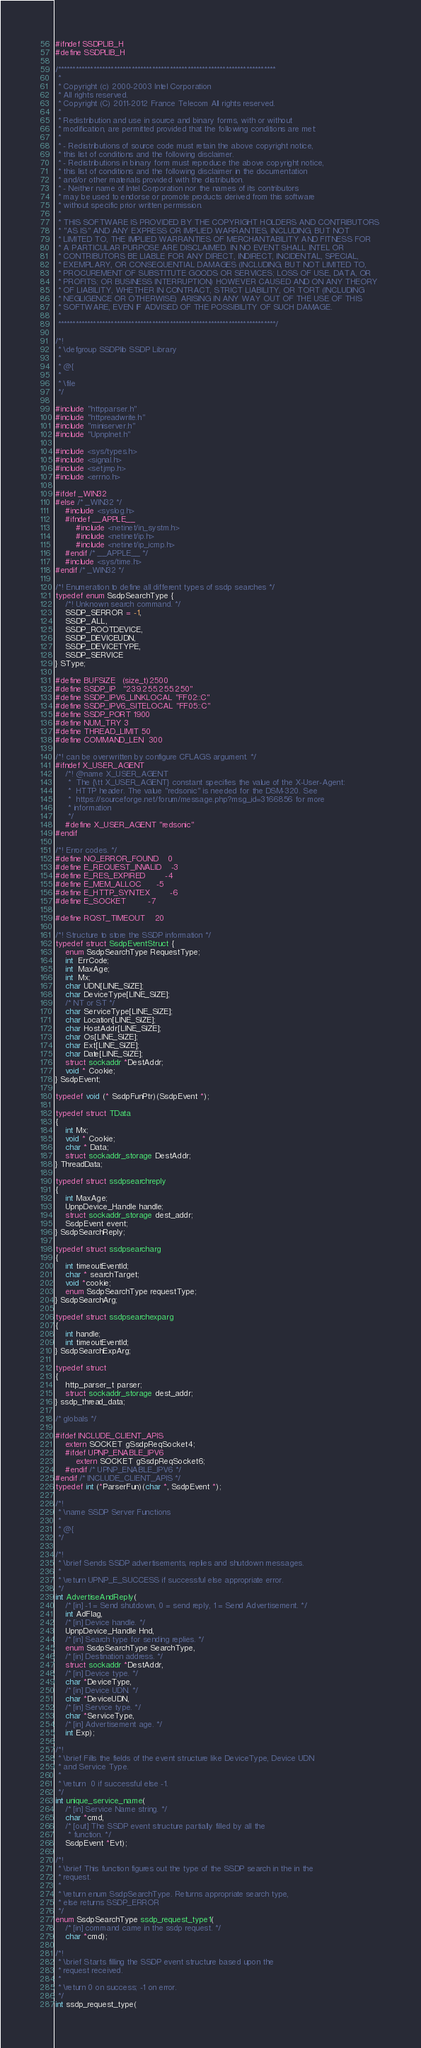<code> <loc_0><loc_0><loc_500><loc_500><_C_>#ifndef SSDPLIB_H
#define SSDPLIB_H 

/**************************************************************************
 *
 * Copyright (c) 2000-2003 Intel Corporation 
 * All rights reserved. 
 * Copyright (C) 2011-2012 France Telecom All rights reserved. 
 *
 * Redistribution and use in source and binary forms, with or without 
 * modification, are permitted provided that the following conditions are met: 
 *
 * - Redistributions of source code must retain the above copyright notice, 
 * this list of conditions and the following disclaimer. 
 * - Redistributions in binary form must reproduce the above copyright notice, 
 * this list of conditions and the following disclaimer in the documentation 
 * and/or other materials provided with the distribution. 
 * - Neither name of Intel Corporation nor the names of its contributors 
 * may be used to endorse or promote products derived from this software 
 * without specific prior written permission.
 * 
 * THIS SOFTWARE IS PROVIDED BY THE COPYRIGHT HOLDERS AND CONTRIBUTORS 
 * "AS IS" AND ANY EXPRESS OR IMPLIED WARRANTIES, INCLUDING, BUT NOT 
 * LIMITED TO, THE IMPLIED WARRANTIES OF MERCHANTABILITY AND FITNESS FOR 
 * A PARTICULAR PURPOSE ARE DISCLAIMED. IN NO EVENT SHALL INTEL OR 
 * CONTRIBUTORS BE LIABLE FOR ANY DIRECT, INDIRECT, INCIDENTAL, SPECIAL, 
 * EXEMPLARY, OR CONSEQUENTIAL DAMAGES (INCLUDING, BUT NOT LIMITED TO, 
 * PROCUREMENT OF SUBSTITUTE GOODS OR SERVICES; LOSS OF USE, DATA, OR 
 * PROFITS; OR BUSINESS INTERRUPTION) HOWEVER CAUSED AND ON ANY THEORY 
 * OF LIABILITY, WHETHER IN CONTRACT, STRICT LIABILITY, OR TORT (INCLUDING
 * NEGLIGENCE OR OTHERWISE) ARISING IN ANY WAY OUT OF THE USE OF THIS 
 * SOFTWARE, EVEN IF ADVISED OF THE POSSIBILITY OF SUCH DAMAGE.
 *
 **************************************************************************/

/*!
 * \defgroup SSDPlib SSDP Library
 *
 * @{
 *
 * \file
 */

#include "httpparser.h"
#include "httpreadwrite.h"
#include "miniserver.h"
#include "UpnpInet.h"

#include <sys/types.h>
#include <signal.h>
#include <setjmp.h>
#include <errno.h>

#ifdef _WIN32
#else /* _WIN32 */
	#include <syslog.h>
	#ifndef __APPLE__
		#include <netinet/in_systm.h>
		#include <netinet/ip.h>
		#include <netinet/ip_icmp.h>
	#endif /* __APPLE__ */
	#include <sys/time.h>
#endif /* _WIN32 */

/*! Enumeration to define all different types of ssdp searches */
typedef enum SsdpSearchType {
	/*! Unknown search command. */
	SSDP_SERROR = -1,
	SSDP_ALL,
	SSDP_ROOTDEVICE,
	SSDP_DEVICEUDN,
	SSDP_DEVICETYPE,
	SSDP_SERVICE
} SType;

#define BUFSIZE   (size_t)2500
#define SSDP_IP   "239.255.255.250"
#define SSDP_IPV6_LINKLOCAL "FF02::C"
#define SSDP_IPV6_SITELOCAL "FF05::C"
#define SSDP_PORT 1900
#define NUM_TRY 3
#define THREAD_LIMIT 50
#define COMMAND_LEN  300

/*! can be overwritten by configure CFLAGS argument. */
#ifndef X_USER_AGENT
	/*! @name X_USER_AGENT
	 *  The {\tt X_USER_AGENT} constant specifies the value of the X-User-Agent:
	 *  HTTP header. The value "redsonic" is needed for the DSM-320. See
	 *  https://sourceforge.net/forum/message.php?msg_id=3166856 for more
	 * information
	 */
	#define X_USER_AGENT "redsonic"
#endif

/*! Error codes. */
#define NO_ERROR_FOUND    0
#define E_REQUEST_INVALID  	-3
#define E_RES_EXPIRED		-4
#define E_MEM_ALLOC		-5
#define E_HTTP_SYNTEX		-6
#define E_SOCKET 		-7

#define RQST_TIMEOUT    20

/*! Structure to store the SSDP information */
typedef struct SsdpEventStruct {
	enum SsdpSearchType RequestType;
	int  ErrCode;
	int  MaxAge;
	int  Mx;
	char UDN[LINE_SIZE];
	char DeviceType[LINE_SIZE];
	/* NT or ST */
	char ServiceType[LINE_SIZE];
	char Location[LINE_SIZE];
	char HostAddr[LINE_SIZE];
	char Os[LINE_SIZE];
	char Ext[LINE_SIZE];
	char Date[LINE_SIZE];
	struct sockaddr *DestAddr;
	void * Cookie;
} SsdpEvent;

typedef void (* SsdpFunPtr)(SsdpEvent *);

typedef struct TData
{
	int Mx;
	void * Cookie;
	char * Data;
	struct sockaddr_storage DestAddr;
} ThreadData;

typedef struct ssdpsearchreply
{
	int MaxAge;
	UpnpDevice_Handle handle;
	struct sockaddr_storage dest_addr;
	SsdpEvent event;
} SsdpSearchReply;

typedef struct ssdpsearcharg
{
	int timeoutEventId;
	char * searchTarget;
	void *cookie;
	enum SsdpSearchType requestType;
} SsdpSearchArg;

typedef struct ssdpsearchexparg
{
	int handle;
	int timeoutEventId;
} SsdpSearchExpArg;

typedef struct
{
	http_parser_t parser;
	struct sockaddr_storage dest_addr;
} ssdp_thread_data;

/* globals */

#ifdef INCLUDE_CLIENT_APIS
	extern SOCKET gSsdpReqSocket4;
	#ifdef UPNP_ENABLE_IPV6
		extern SOCKET gSsdpReqSocket6;
	#endif /* UPNP_ENABLE_IPV6 */
#endif /* INCLUDE_CLIENT_APIS */
typedef int (*ParserFun)(char *, SsdpEvent *);

/*!
 * \name SSDP Server Functions
 *
 * @{
 */

/*!
 * \brief Sends SSDP advertisements, replies and shutdown messages.
 *
 * \return UPNP_E_SUCCESS if successful else appropriate error.
 */
int AdvertiseAndReply(
	/* [in] -1 = Send shutdown, 0 = send reply, 1 = Send Advertisement. */
	int AdFlag, 
	/* [in] Device handle. */
	UpnpDevice_Handle Hnd, 
	/* [in] Search type for sending replies. */
	enum SsdpSearchType SearchType, 
	/* [in] Destination address. */
	struct sockaddr *DestAddr,
	/* [in] Device type. */
	char *DeviceType, 
	/* [in] Device UDN. */
	char *DeviceUDN, 
	/* [in] Service type. */
	char *ServiceType,
	/* [in] Advertisement age. */
	int Exp);

/*!
 * \brief Fills the fields of the event structure like DeviceType, Device UDN
 * and Service Type.
 *
 * \return  0 if successful else -1.
 */
int unique_service_name(
	/* [in] Service Name string. */
	char *cmd,
	/* [out] The SSDP event structure partially filled by all the
	 * function. */
	SsdpEvent *Evt);

/*!
 * \brief This function figures out the type of the SSDP search in the in the
 * request.
 *
 * \return enum SsdpSearchType. Returns appropriate search type,
 * else returns SSDP_ERROR
 */
enum SsdpSearchType ssdp_request_type1(
	/* [in] command came in the ssdp request. */
	char *cmd);

/*!
 * \brief Starts filling the SSDP event structure based upon the
 * request received.
 *
 * \return 0 on success; -1 on error.
 */
int ssdp_request_type(</code> 